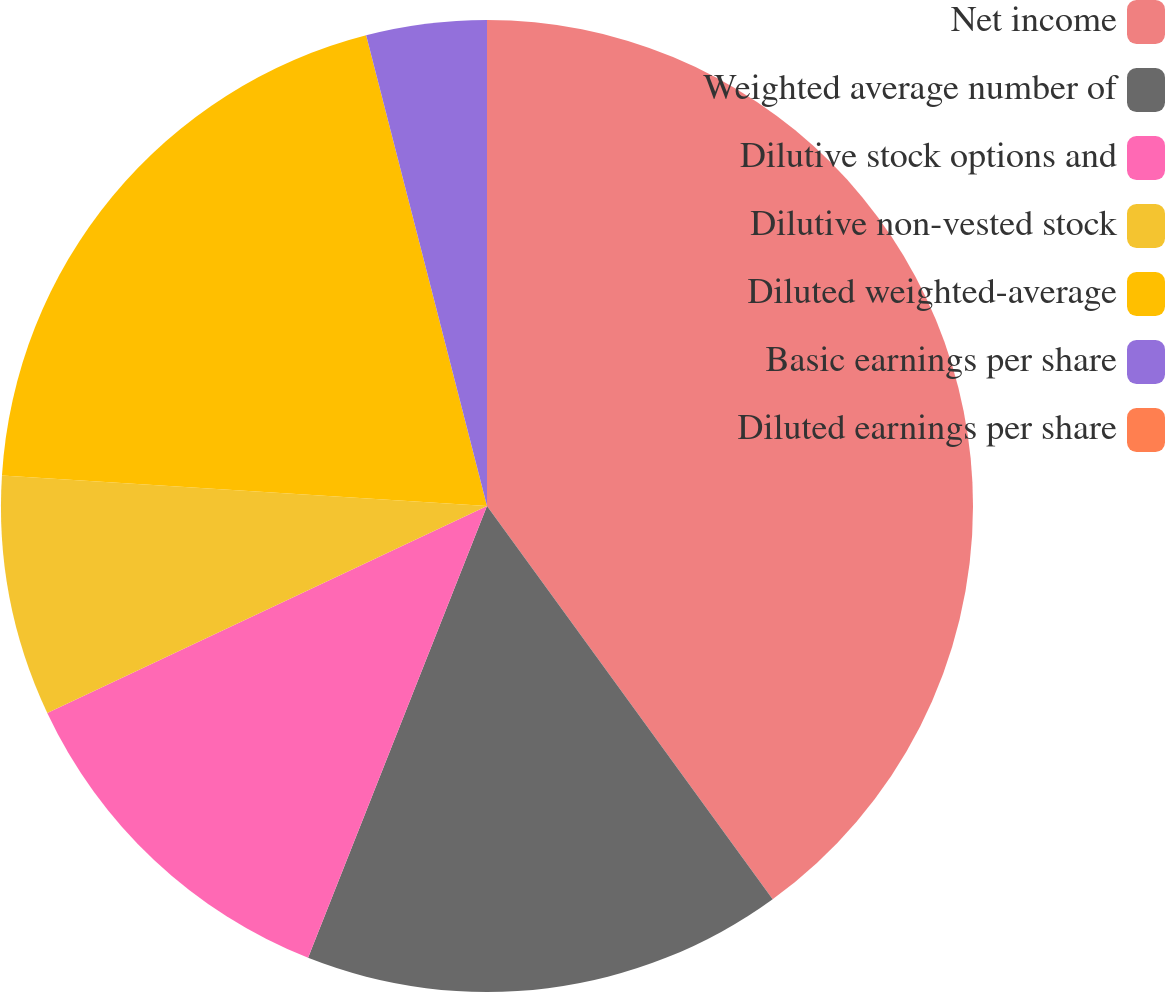Convert chart to OTSL. <chart><loc_0><loc_0><loc_500><loc_500><pie_chart><fcel>Net income<fcel>Weighted average number of<fcel>Dilutive stock options and<fcel>Dilutive non-vested stock<fcel>Diluted weighted-average<fcel>Basic earnings per share<fcel>Diluted earnings per share<nl><fcel>40.0%<fcel>16.0%<fcel>12.0%<fcel>8.0%<fcel>20.0%<fcel>4.0%<fcel>0.0%<nl></chart> 